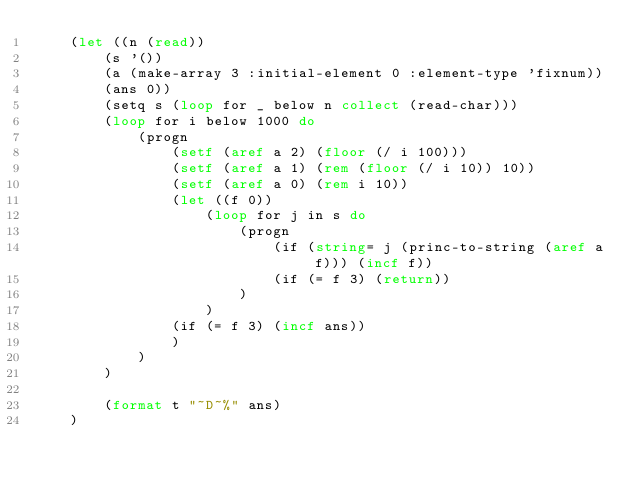<code> <loc_0><loc_0><loc_500><loc_500><_Lisp_>    (let ((n (read))
        (s '())
        (a (make-array 3 :initial-element 0 :element-type 'fixnum))
        (ans 0))
        (setq s (loop for _ below n collect (read-char)))
        (loop for i below 1000 do
            (progn
                (setf (aref a 2) (floor (/ i 100)))
                (setf (aref a 1) (rem (floor (/ i 10)) 10))
                (setf (aref a 0) (rem i 10))
                (let ((f 0))
                    (loop for j in s do
                        (progn
                            (if (string= j (princ-to-string (aref a f))) (incf f))
                            (if (= f 3) (return))
                        )
                    )
                (if (= f 3) (incf ans))
                )
            )
        )
     
        (format t "~D~%" ans)
    )</code> 